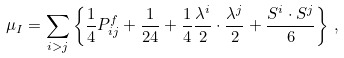Convert formula to latex. <formula><loc_0><loc_0><loc_500><loc_500>\mu _ { I } = \sum _ { i > j } \left \{ \frac { 1 } { 4 } P _ { i j } ^ { f } + \frac { 1 } { 2 4 } + \frac { 1 } { 4 } \frac { \lambda ^ { i } } { 2 } \cdot \frac { \lambda ^ { j } } { 2 } + \frac { S ^ { i } \cdot S ^ { j } } { 6 } \right \} \, ,</formula> 